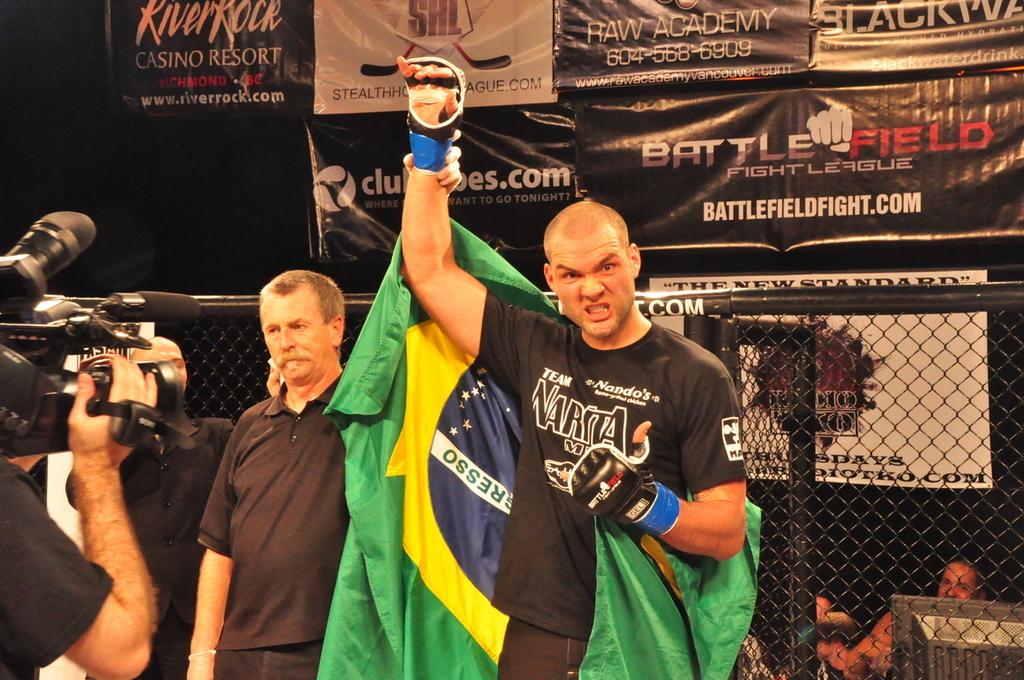What is the name of the fight league shown on the banner?
Your answer should be compact. Battlefield. 